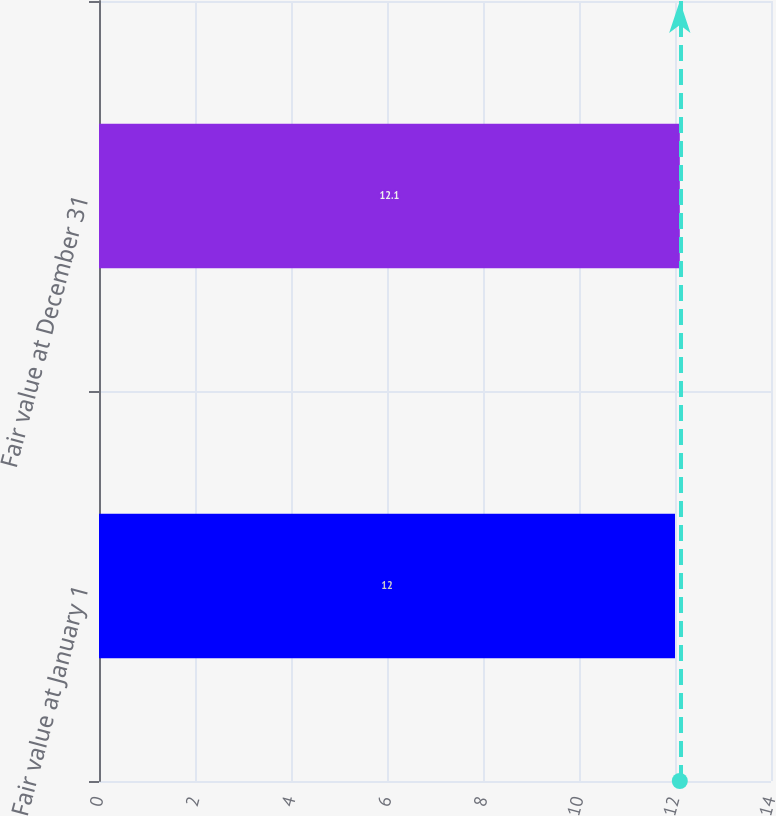Convert chart to OTSL. <chart><loc_0><loc_0><loc_500><loc_500><bar_chart><fcel>Fair value at January 1<fcel>Fair value at December 31<nl><fcel>12<fcel>12.1<nl></chart> 